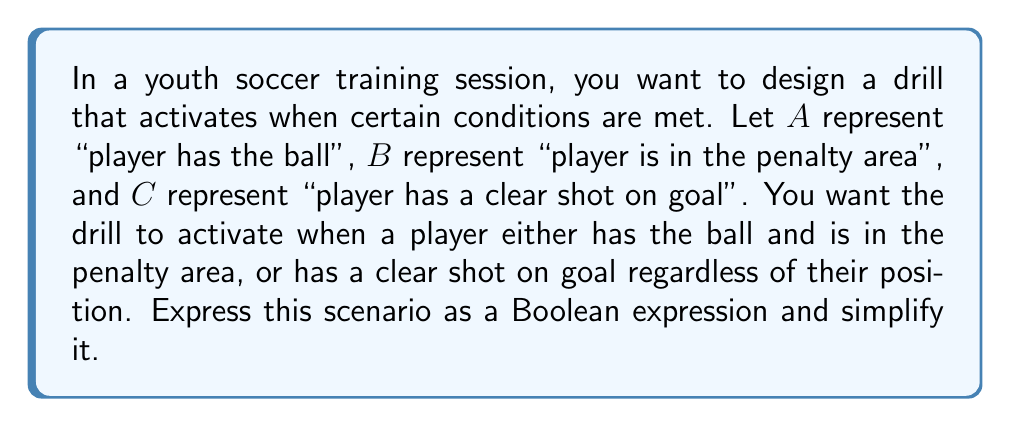Solve this math problem. Let's approach this step-by-step:

1) First, let's translate the given conditions into a Boolean expression:
   $$(A \land B) \lor C$$

2) This expression is already relatively simple, but we can verify if it can be simplified further using Boolean algebra laws.

3) We can apply the distributive law: $X \lor (Y \land Z) = (X \lor Y) \land (X \lor Z)$
   In our case, $X = C$, $Y = A$, and $Z = B$

4) Applying this law:
   $$(A \land B) \lor C = (C \lor A) \land (C \lor B)$$

5) However, this doesn't simplify our expression; it actually makes it more complex.

6) Therefore, the original expression $(A \land B) \lor C$ is already in its simplest form.

This Boolean expression accurately represents the scenario where the drill activates when a player either has the ball and is in the penalty area, or has a clear shot on goal regardless of their position.
Answer: $$(A \land B) \lor C$$ 